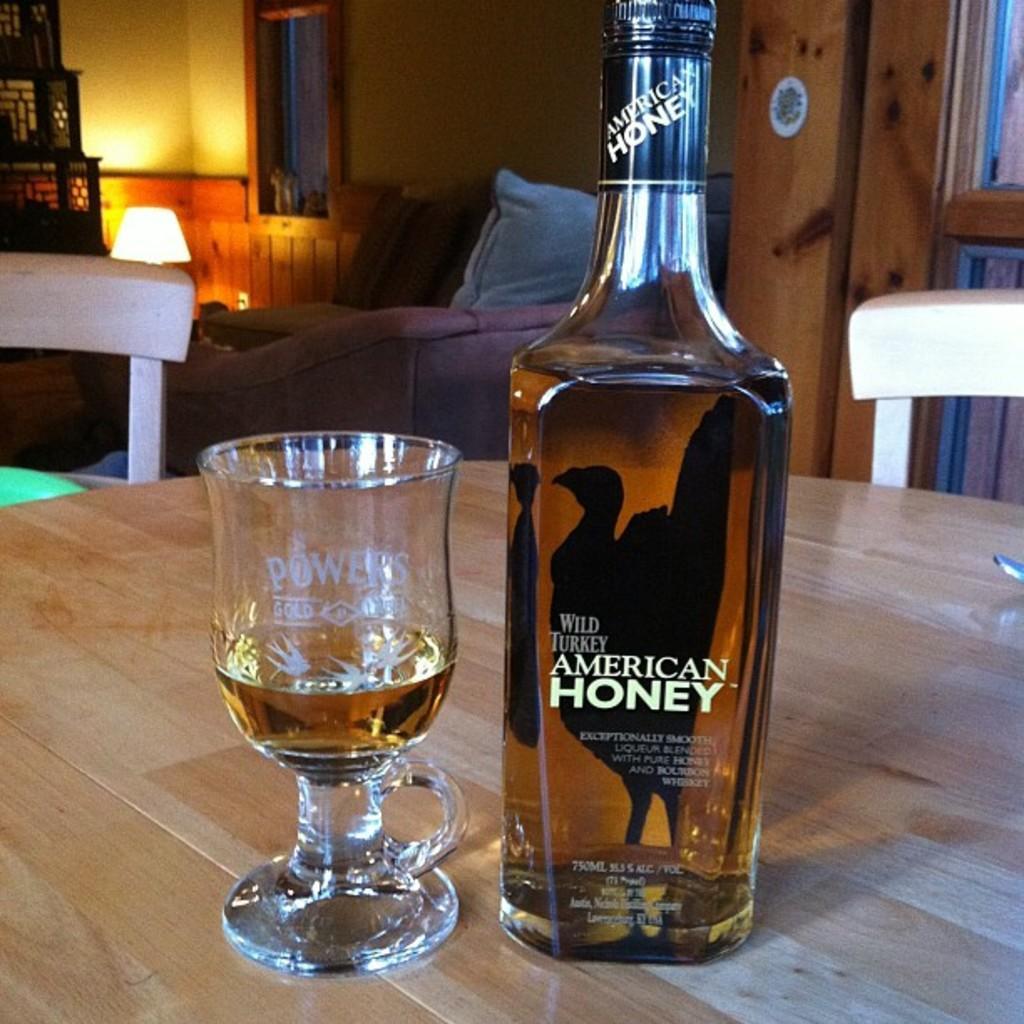Can you describe this image briefly? In the foreground of this picture we can see a glass bottle containing drink and we can see the text and some picture on the bottle and we can see a glass of drink and both of them are placed on the top of the wooden table. In the background we can see the chairs, bed, pillows and blanket on the bed and we can see the windows, wall, lamp and some other objects. 